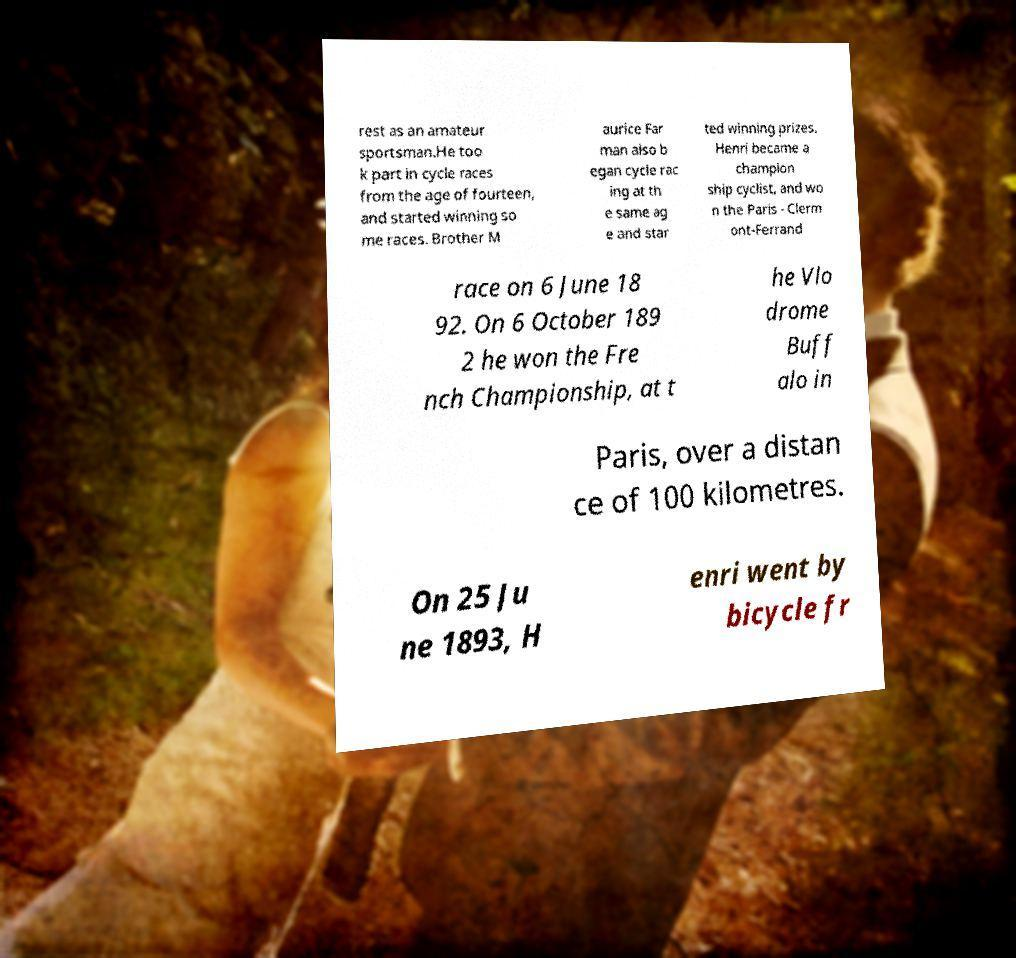Could you extract and type out the text from this image? rest as an amateur sportsman.He too k part in cycle races from the age of fourteen, and started winning so me races. Brother M aurice Far man also b egan cycle rac ing at th e same ag e and star ted winning prizes. Henri became a champion ship cyclist, and wo n the Paris - Clerm ont-Ferrand race on 6 June 18 92. On 6 October 189 2 he won the Fre nch Championship, at t he Vlo drome Buff alo in Paris, over a distan ce of 100 kilometres. On 25 Ju ne 1893, H enri went by bicycle fr 